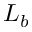<formula> <loc_0><loc_0><loc_500><loc_500>L _ { b }</formula> 